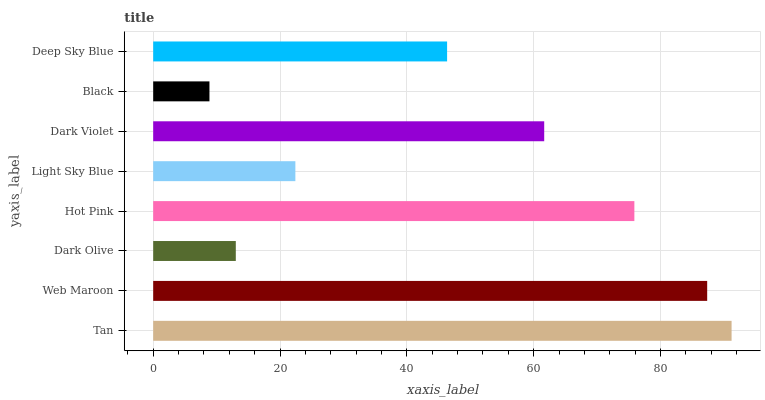Is Black the minimum?
Answer yes or no. Yes. Is Tan the maximum?
Answer yes or no. Yes. Is Web Maroon the minimum?
Answer yes or no. No. Is Web Maroon the maximum?
Answer yes or no. No. Is Tan greater than Web Maroon?
Answer yes or no. Yes. Is Web Maroon less than Tan?
Answer yes or no. Yes. Is Web Maroon greater than Tan?
Answer yes or no. No. Is Tan less than Web Maroon?
Answer yes or no. No. Is Dark Violet the high median?
Answer yes or no. Yes. Is Deep Sky Blue the low median?
Answer yes or no. Yes. Is Tan the high median?
Answer yes or no. No. Is Web Maroon the low median?
Answer yes or no. No. 